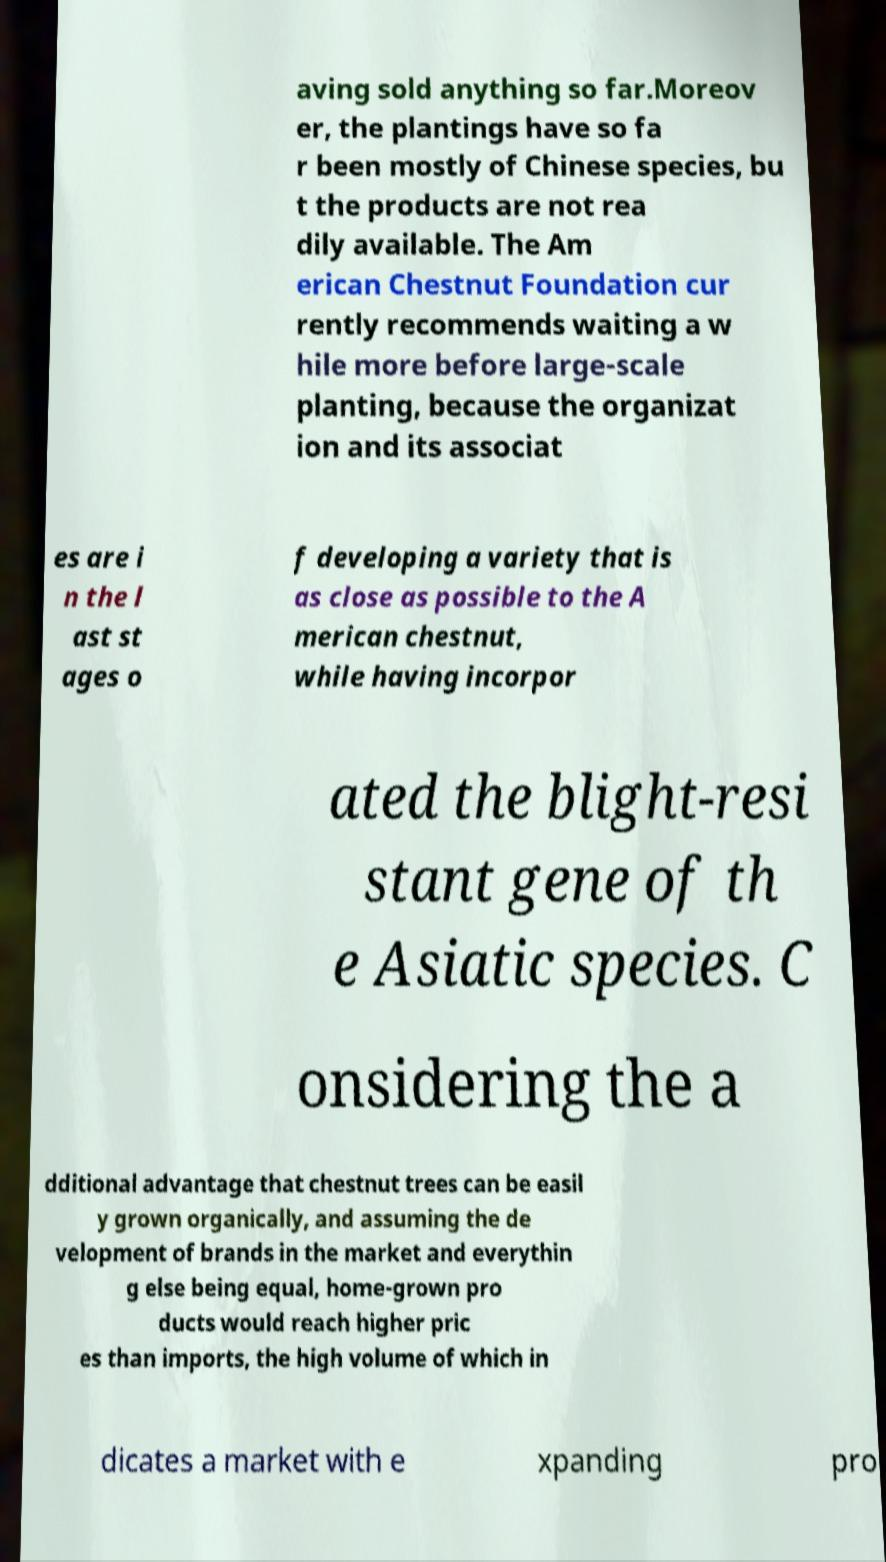Please identify and transcribe the text found in this image. aving sold anything so far.Moreov er, the plantings have so fa r been mostly of Chinese species, bu t the products are not rea dily available. The Am erican Chestnut Foundation cur rently recommends waiting a w hile more before large-scale planting, because the organizat ion and its associat es are i n the l ast st ages o f developing a variety that is as close as possible to the A merican chestnut, while having incorpor ated the blight-resi stant gene of th e Asiatic species. C onsidering the a dditional advantage that chestnut trees can be easil y grown organically, and assuming the de velopment of brands in the market and everythin g else being equal, home-grown pro ducts would reach higher pric es than imports, the high volume of which in dicates a market with e xpanding pro 